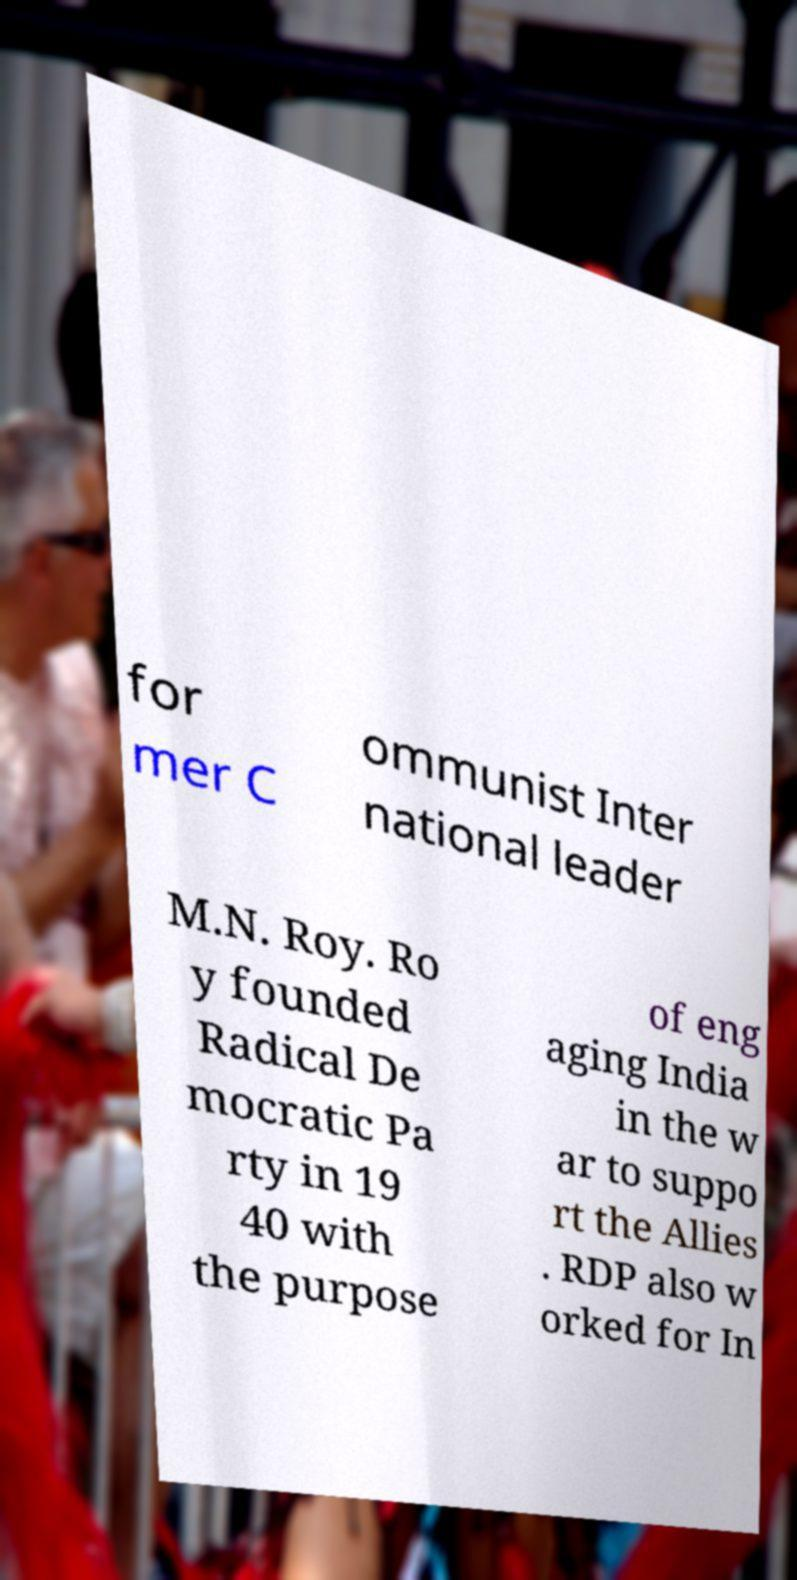For documentation purposes, I need the text within this image transcribed. Could you provide that? for mer C ommunist Inter national leader M.N. Roy. Ro y founded Radical De mocratic Pa rty in 19 40 with the purpose of eng aging India in the w ar to suppo rt the Allies . RDP also w orked for In 